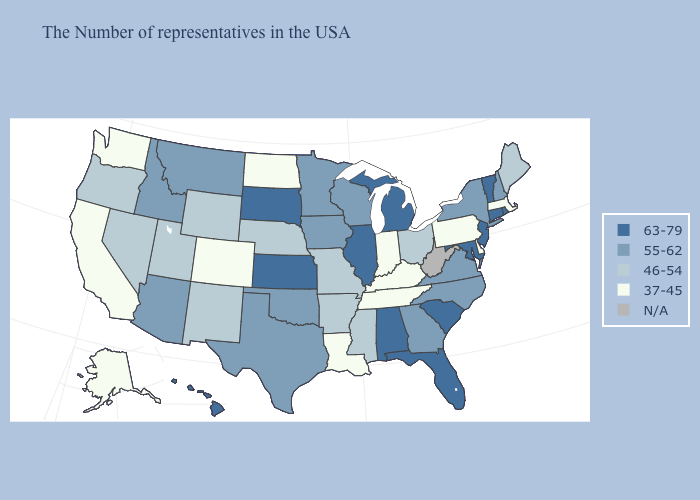Does North Dakota have the lowest value in the MidWest?
Concise answer only. Yes. Name the states that have a value in the range 55-62?
Concise answer only. New Hampshire, New York, Virginia, North Carolina, Georgia, Wisconsin, Minnesota, Iowa, Oklahoma, Texas, Montana, Arizona, Idaho. What is the lowest value in states that border New Mexico?
Write a very short answer. 37-45. What is the highest value in the USA?
Be succinct. 63-79. Does the first symbol in the legend represent the smallest category?
Short answer required. No. What is the highest value in states that border Louisiana?
Write a very short answer. 55-62. Name the states that have a value in the range 37-45?
Write a very short answer. Massachusetts, Delaware, Pennsylvania, Kentucky, Indiana, Tennessee, Louisiana, North Dakota, Colorado, California, Washington, Alaska. Among the states that border Idaho , which have the lowest value?
Short answer required. Washington. What is the lowest value in the South?
Quick response, please. 37-45. Which states have the highest value in the USA?
Give a very brief answer. Rhode Island, Vermont, Connecticut, New Jersey, Maryland, South Carolina, Florida, Michigan, Alabama, Illinois, Kansas, South Dakota, Hawaii. Name the states that have a value in the range N/A?
Give a very brief answer. West Virginia. Name the states that have a value in the range 55-62?
Answer briefly. New Hampshire, New York, Virginia, North Carolina, Georgia, Wisconsin, Minnesota, Iowa, Oklahoma, Texas, Montana, Arizona, Idaho. Name the states that have a value in the range N/A?
Be succinct. West Virginia. How many symbols are there in the legend?
Keep it brief. 5. Is the legend a continuous bar?
Keep it brief. No. 